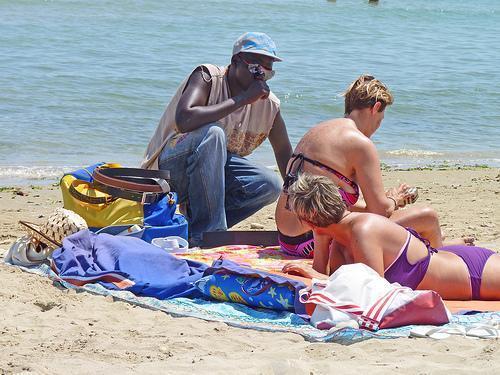How many people are on the beach?
Give a very brief answer. 3. How many men are in the scene?
Give a very brief answer. 1. How many pieces is the purple bathing suit?
Give a very brief answer. 2. How many yellow bags do you see?
Give a very brief answer. 1. How many are wearing sunglasses?
Give a very brief answer. 1. How many people are wearing a hat?
Give a very brief answer. 1. 